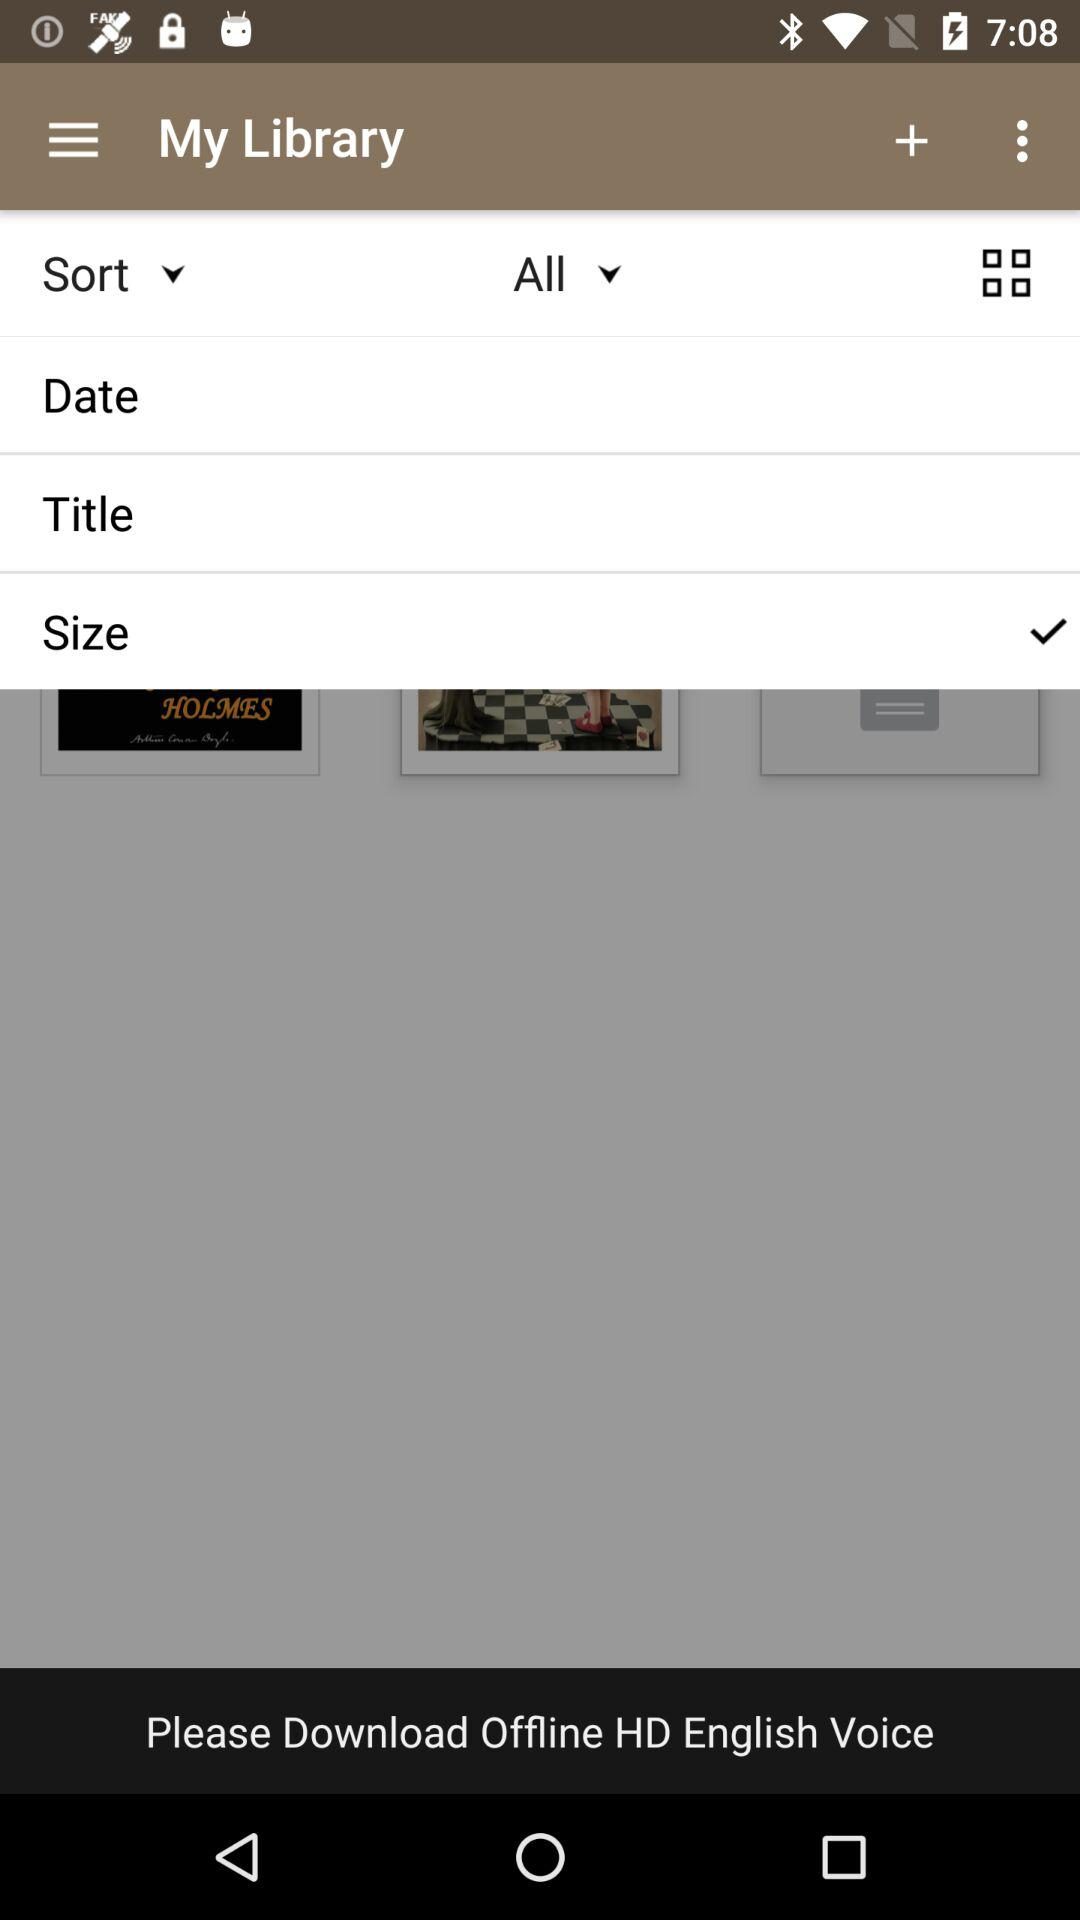Which option is selected? The selected option is "Size". 